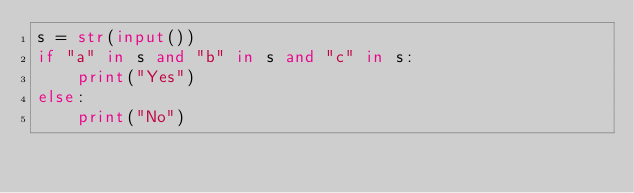<code> <loc_0><loc_0><loc_500><loc_500><_Python_>s = str(input())
if "a" in s and "b" in s and "c" in s:
    print("Yes")
else:
    print("No")</code> 